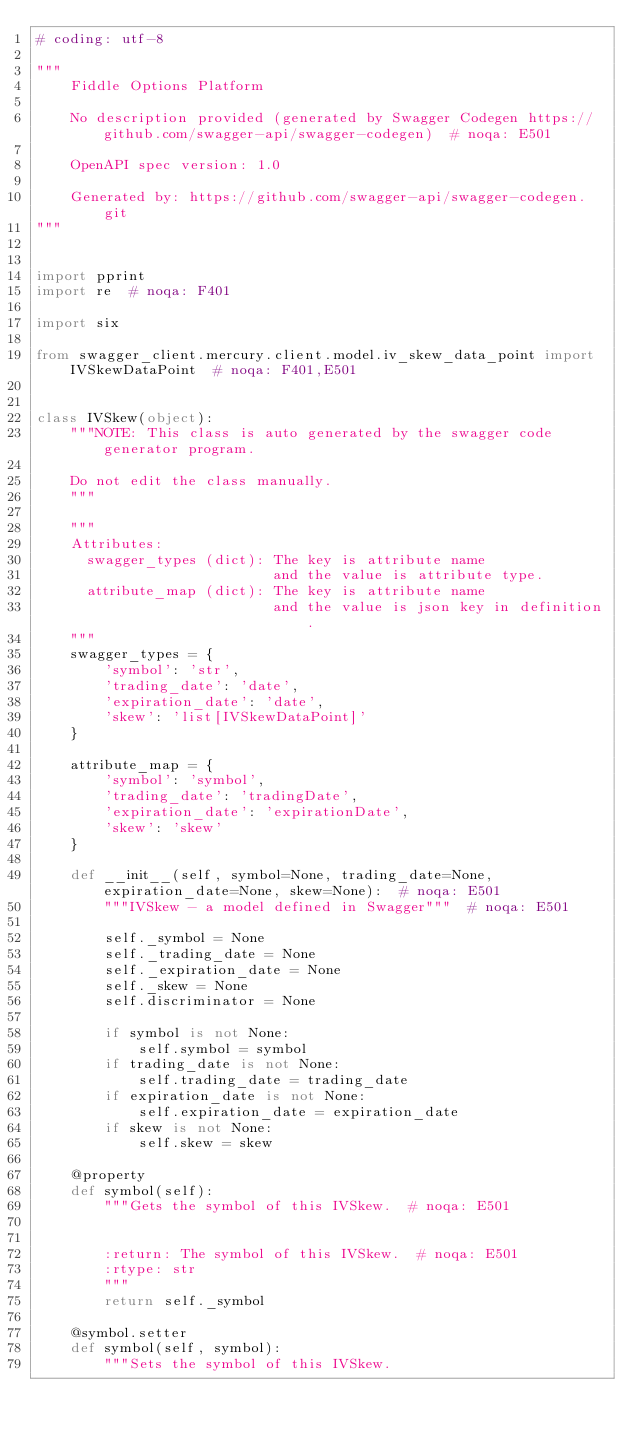<code> <loc_0><loc_0><loc_500><loc_500><_Python_># coding: utf-8

"""
    Fiddle Options Platform

    No description provided (generated by Swagger Codegen https://github.com/swagger-api/swagger-codegen)  # noqa: E501

    OpenAPI spec version: 1.0
    
    Generated by: https://github.com/swagger-api/swagger-codegen.git
"""


import pprint
import re  # noqa: F401

import six

from swagger_client.mercury.client.model.iv_skew_data_point import IVSkewDataPoint  # noqa: F401,E501


class IVSkew(object):
    """NOTE: This class is auto generated by the swagger code generator program.

    Do not edit the class manually.
    """

    """
    Attributes:
      swagger_types (dict): The key is attribute name
                            and the value is attribute type.
      attribute_map (dict): The key is attribute name
                            and the value is json key in definition.
    """
    swagger_types = {
        'symbol': 'str',
        'trading_date': 'date',
        'expiration_date': 'date',
        'skew': 'list[IVSkewDataPoint]'
    }

    attribute_map = {
        'symbol': 'symbol',
        'trading_date': 'tradingDate',
        'expiration_date': 'expirationDate',
        'skew': 'skew'
    }

    def __init__(self, symbol=None, trading_date=None, expiration_date=None, skew=None):  # noqa: E501
        """IVSkew - a model defined in Swagger"""  # noqa: E501

        self._symbol = None
        self._trading_date = None
        self._expiration_date = None
        self._skew = None
        self.discriminator = None

        if symbol is not None:
            self.symbol = symbol
        if trading_date is not None:
            self.trading_date = trading_date
        if expiration_date is not None:
            self.expiration_date = expiration_date
        if skew is not None:
            self.skew = skew

    @property
    def symbol(self):
        """Gets the symbol of this IVSkew.  # noqa: E501


        :return: The symbol of this IVSkew.  # noqa: E501
        :rtype: str
        """
        return self._symbol

    @symbol.setter
    def symbol(self, symbol):
        """Sets the symbol of this IVSkew.

</code> 